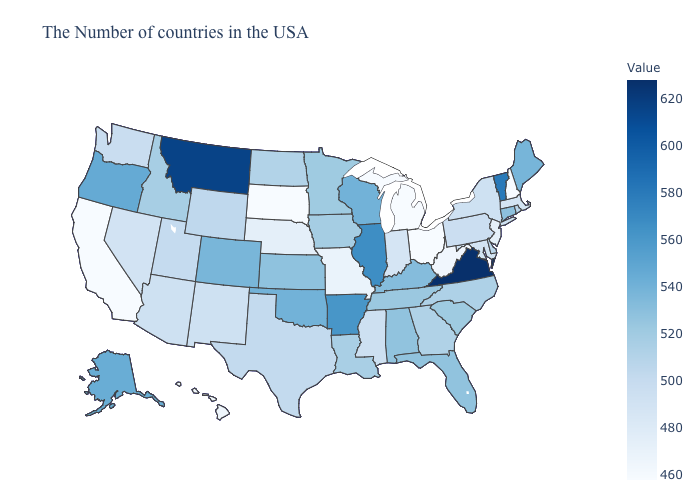Is the legend a continuous bar?
Be succinct. Yes. Does Nevada have the highest value in the USA?
Give a very brief answer. No. Does the map have missing data?
Be succinct. No. Among the states that border Florida , does Alabama have the highest value?
Quick response, please. Yes. Which states have the highest value in the USA?
Concise answer only. Virginia. Does Arkansas have a lower value than Kentucky?
Be succinct. No. Which states hav the highest value in the West?
Give a very brief answer. Montana. Does Oklahoma have the highest value in the USA?
Quick response, please. No. 